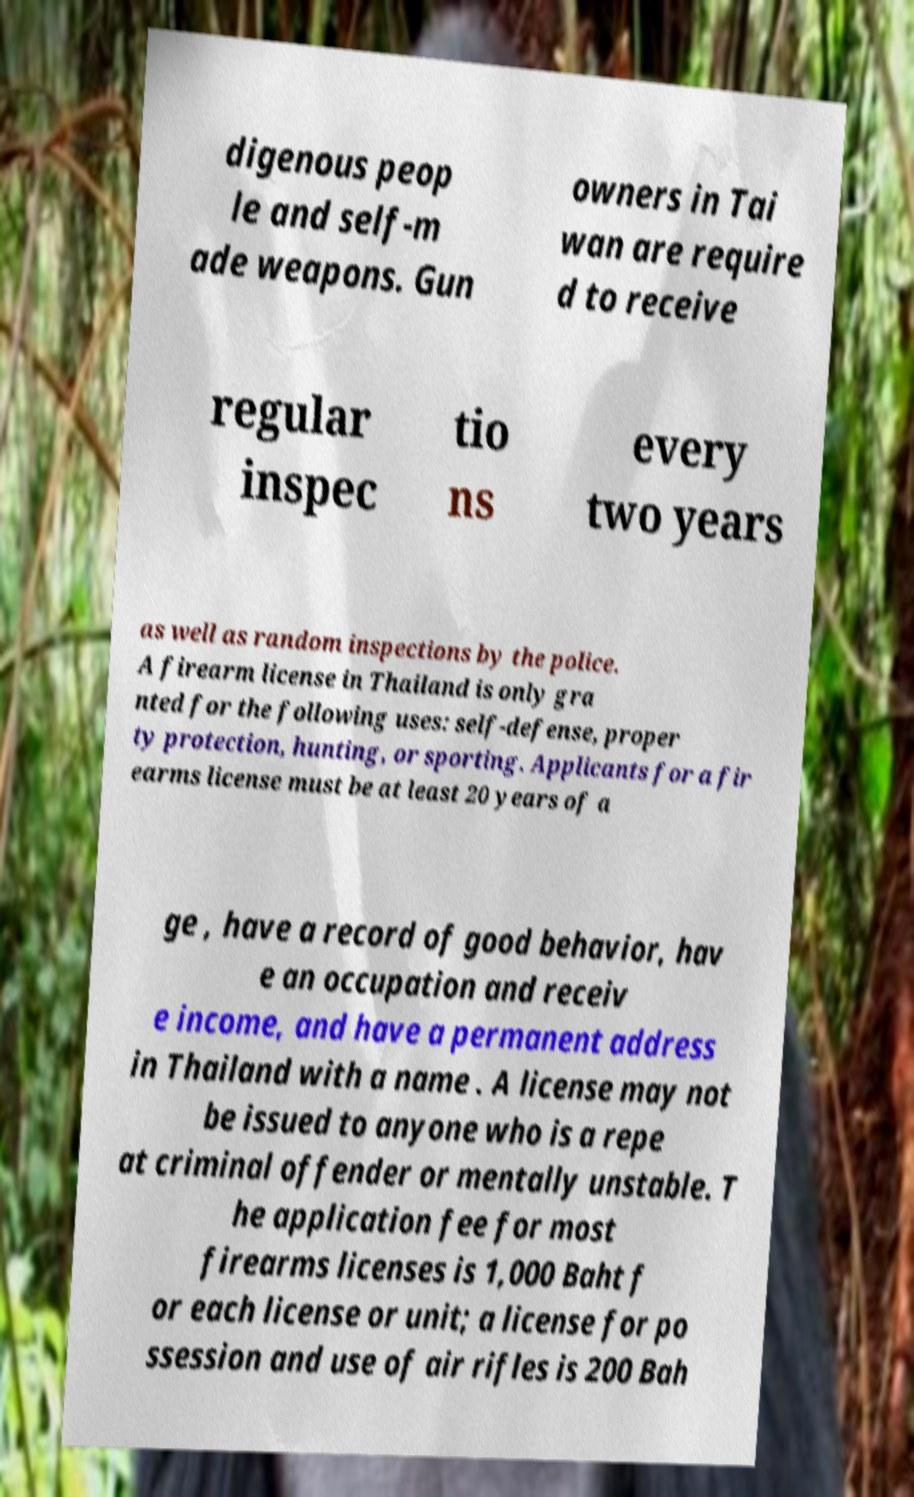I need the written content from this picture converted into text. Can you do that? digenous peop le and self-m ade weapons. Gun owners in Tai wan are require d to receive regular inspec tio ns every two years as well as random inspections by the police. A firearm license in Thailand is only gra nted for the following uses: self-defense, proper ty protection, hunting, or sporting. Applicants for a fir earms license must be at least 20 years of a ge , have a record of good behavior, hav e an occupation and receiv e income, and have a permanent address in Thailand with a name . A license may not be issued to anyone who is a repe at criminal offender or mentally unstable. T he application fee for most firearms licenses is 1,000 Baht f or each license or unit; a license for po ssession and use of air rifles is 200 Bah 